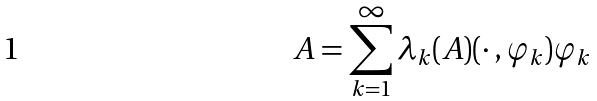Convert formula to latex. <formula><loc_0><loc_0><loc_500><loc_500>A = \sum _ { k = 1 } ^ { \infty } \lambda _ { k } ( A ) ( \cdot \, , \varphi _ { k } ) \varphi _ { k }</formula> 